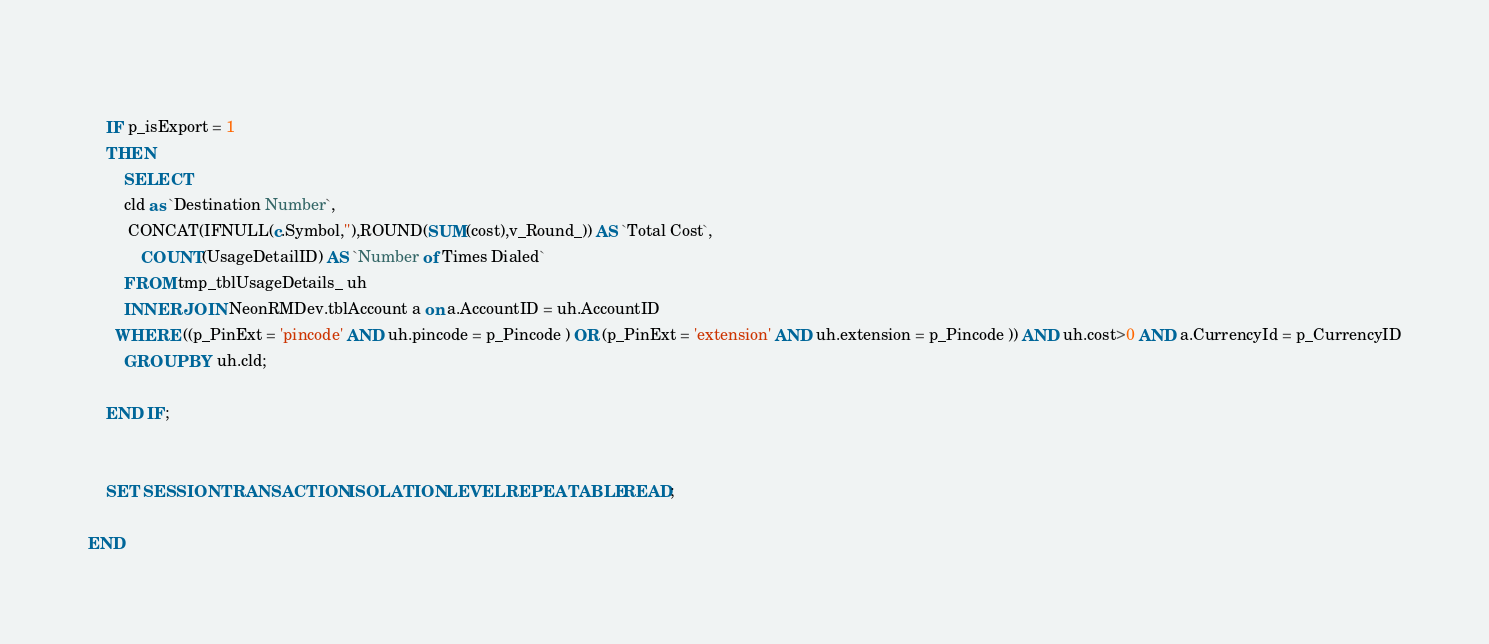Convert code to text. <code><loc_0><loc_0><loc_500><loc_500><_SQL_>	
	IF p_isExport = 1
	THEN
		SELECT
      	cld as `Destination Number`,
         CONCAT(IFNULL(c.Symbol,''),ROUND(SUM(cost),v_Round_)) AS `Total Cost`,
 			COUNT(UsageDetailID) AS `Number of Times Dialed`
		FROM tmp_tblUsageDetails_ uh
		INNER JOIN NeonRMDev.tblAccount a on a.AccountID = uh.AccountID
      WHERE ((p_PinExt = 'pincode' AND uh.pincode = p_Pincode ) OR (p_PinExt = 'extension' AND uh.extension = p_Pincode )) AND uh.cost>0 AND a.CurrencyId = p_CurrencyID
		GROUP BY uh.cld;
	
	END IF;
	
	
	SET SESSION TRANSACTION ISOLATION LEVEL REPEATABLE READ;

END</code> 